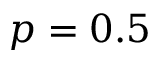<formula> <loc_0><loc_0><loc_500><loc_500>p = 0 . 5</formula> 